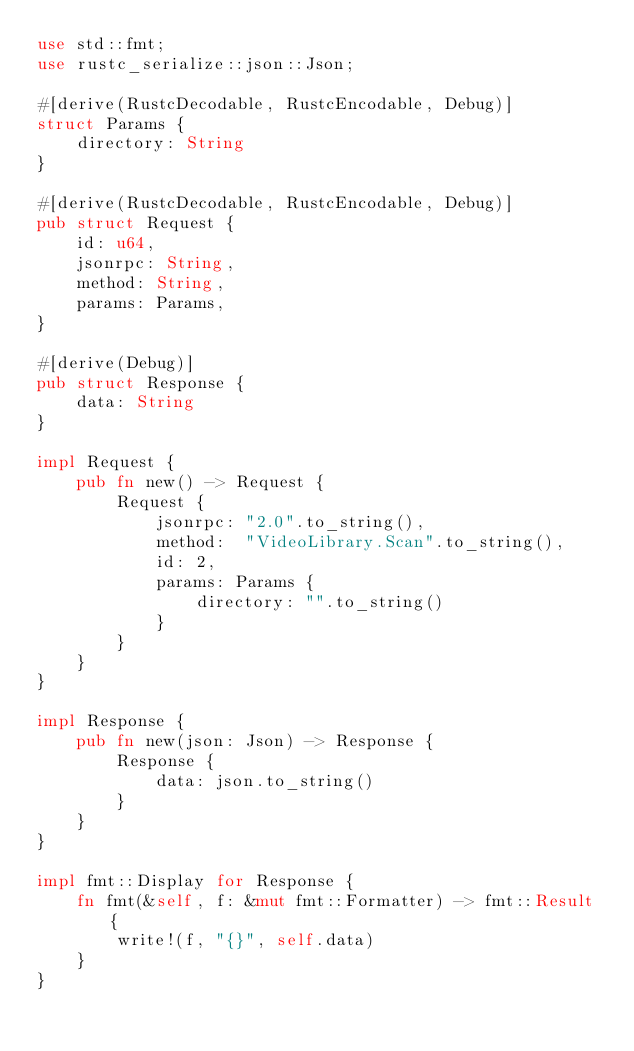Convert code to text. <code><loc_0><loc_0><loc_500><loc_500><_Rust_>use std::fmt;
use rustc_serialize::json::Json;

#[derive(RustcDecodable, RustcEncodable, Debug)]
struct Params {
	directory: String
}

#[derive(RustcDecodable, RustcEncodable, Debug)]
pub struct Request {
    id: u64,
    jsonrpc: String,
    method: String,
    params: Params,
}

#[derive(Debug)]
pub struct Response {
    data: String
}

impl Request {
    pub fn new() -> Request {
        Request {
            jsonrpc: "2.0".to_string(),
            method:  "VideoLibrary.Scan".to_string(),
            id: 2,
            params: Params {
            	directory: "".to_string()
            }
        }
    }
}

impl Response {
    pub fn new(json: Json) -> Response {
        Response {
            data: json.to_string()
        }
    }
}

impl fmt::Display for Response {
    fn fmt(&self, f: &mut fmt::Formatter) -> fmt::Result {
        write!(f, "{}", self.data)
    }
}
</code> 